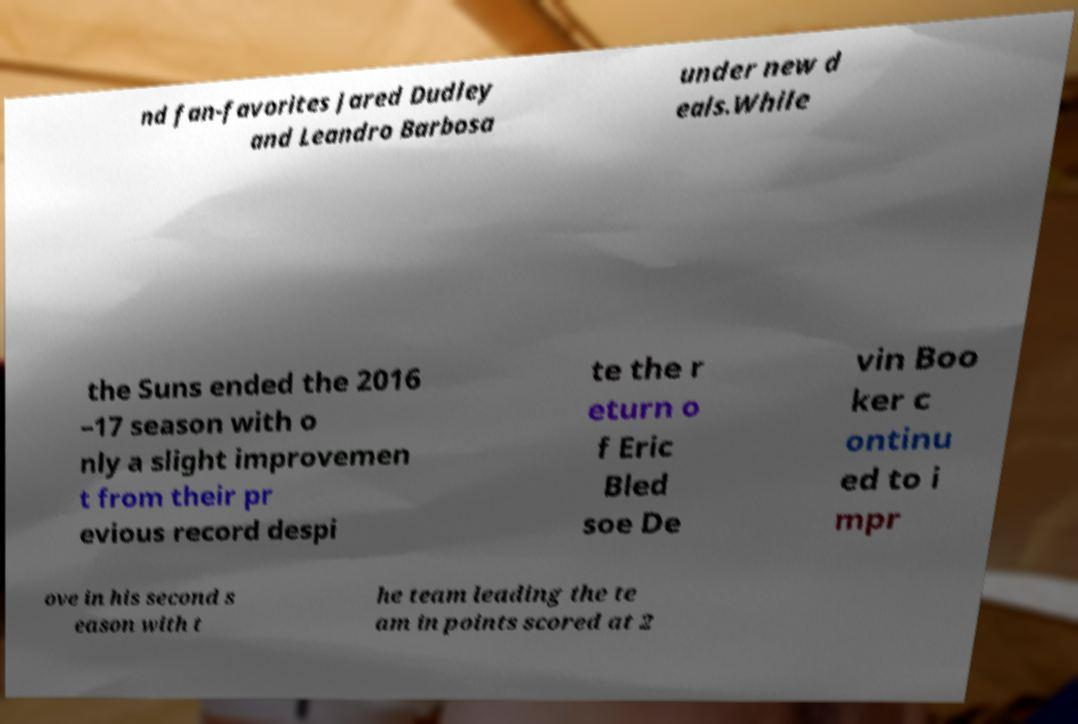Could you extract and type out the text from this image? nd fan-favorites Jared Dudley and Leandro Barbosa under new d eals.While the Suns ended the 2016 –17 season with o nly a slight improvemen t from their pr evious record despi te the r eturn o f Eric Bled soe De vin Boo ker c ontinu ed to i mpr ove in his second s eason with t he team leading the te am in points scored at 2 